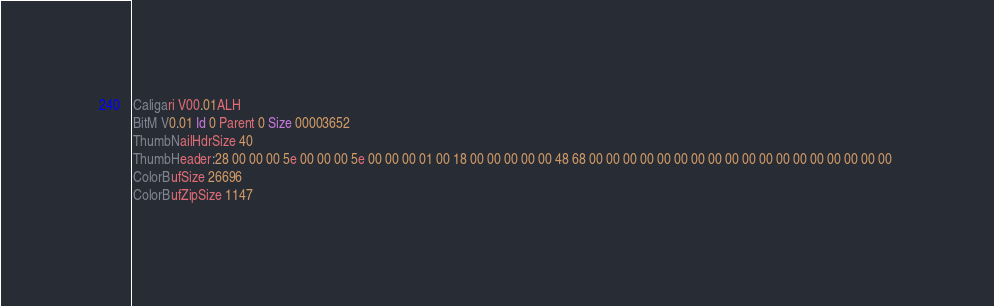Convert code to text. <code><loc_0><loc_0><loc_500><loc_500><_COBOL_>Caligari V00.01ALH             
BitM V0.01 Id 0 Parent 0 Size 00003652
ThumbNailHdrSize 40
ThumbHeader:28 00 00 00 5e 00 00 00 5e 00 00 00 01 00 18 00 00 00 00 00 48 68 00 00 00 00 00 00 00 00 00 00 00 00 00 00 00 00 00 00 
ColorBufSize 26696
ColorBufZipSize 1147</code> 